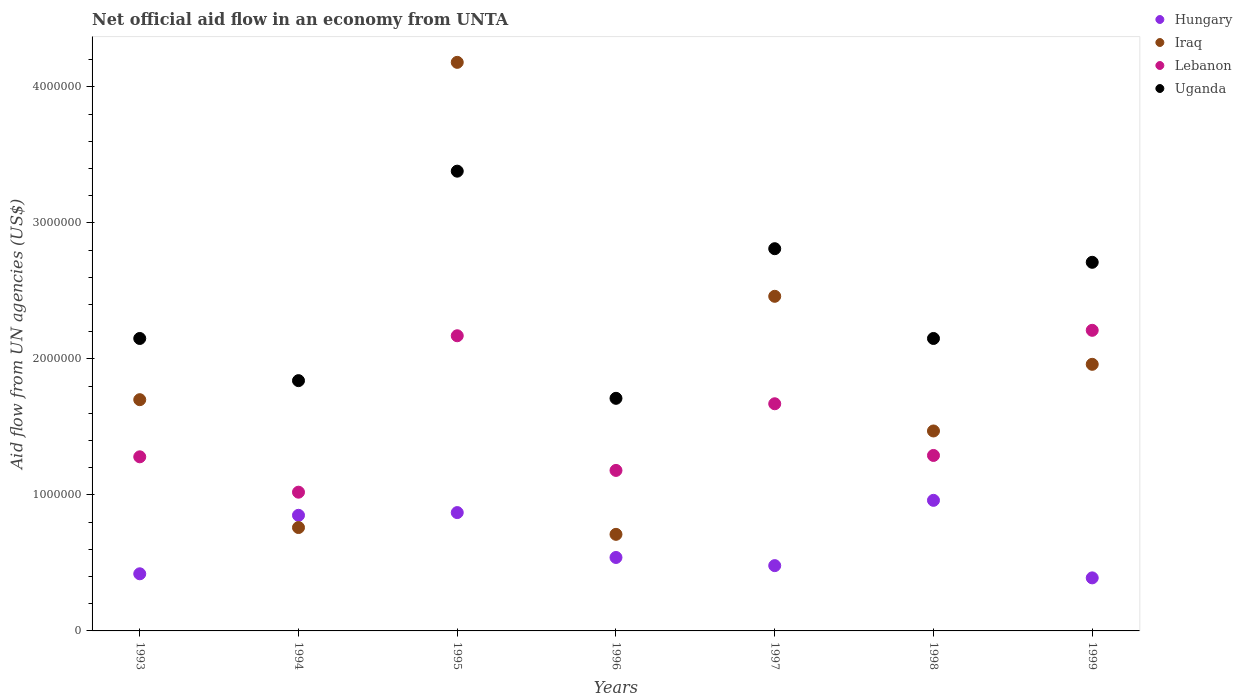Is the number of dotlines equal to the number of legend labels?
Offer a terse response. Yes. What is the net official aid flow in Lebanon in 1996?
Provide a succinct answer. 1.18e+06. Across all years, what is the maximum net official aid flow in Lebanon?
Make the answer very short. 2.21e+06. Across all years, what is the minimum net official aid flow in Iraq?
Make the answer very short. 7.10e+05. What is the total net official aid flow in Hungary in the graph?
Give a very brief answer. 4.51e+06. What is the difference between the net official aid flow in Hungary in 1994 and that in 1996?
Ensure brevity in your answer.  3.10e+05. What is the difference between the net official aid flow in Uganda in 1993 and the net official aid flow in Hungary in 1999?
Ensure brevity in your answer.  1.76e+06. What is the average net official aid flow in Iraq per year?
Keep it short and to the point. 1.89e+06. In the year 1996, what is the difference between the net official aid flow in Hungary and net official aid flow in Uganda?
Offer a very short reply. -1.17e+06. What is the ratio of the net official aid flow in Iraq in 1996 to that in 1997?
Provide a succinct answer. 0.29. Is the net official aid flow in Uganda in 1996 less than that in 1997?
Keep it short and to the point. Yes. Is the difference between the net official aid flow in Hungary in 1995 and 1998 greater than the difference between the net official aid flow in Uganda in 1995 and 1998?
Give a very brief answer. No. What is the difference between the highest and the second highest net official aid flow in Uganda?
Provide a succinct answer. 5.70e+05. What is the difference between the highest and the lowest net official aid flow in Lebanon?
Your answer should be compact. 1.19e+06. In how many years, is the net official aid flow in Iraq greater than the average net official aid flow in Iraq taken over all years?
Offer a very short reply. 3. Is it the case that in every year, the sum of the net official aid flow in Lebanon and net official aid flow in Iraq  is greater than the sum of net official aid flow in Hungary and net official aid flow in Uganda?
Provide a succinct answer. No. Is the net official aid flow in Iraq strictly less than the net official aid flow in Hungary over the years?
Offer a terse response. No. What is the difference between two consecutive major ticks on the Y-axis?
Offer a terse response. 1.00e+06. Does the graph contain grids?
Keep it short and to the point. No. How are the legend labels stacked?
Ensure brevity in your answer.  Vertical. What is the title of the graph?
Offer a very short reply. Net official aid flow in an economy from UNTA. Does "United States" appear as one of the legend labels in the graph?
Make the answer very short. No. What is the label or title of the X-axis?
Make the answer very short. Years. What is the label or title of the Y-axis?
Your answer should be compact. Aid flow from UN agencies (US$). What is the Aid flow from UN agencies (US$) of Iraq in 1993?
Offer a terse response. 1.70e+06. What is the Aid flow from UN agencies (US$) in Lebanon in 1993?
Offer a terse response. 1.28e+06. What is the Aid flow from UN agencies (US$) in Uganda in 1993?
Offer a very short reply. 2.15e+06. What is the Aid flow from UN agencies (US$) in Hungary in 1994?
Offer a terse response. 8.50e+05. What is the Aid flow from UN agencies (US$) in Iraq in 1994?
Provide a short and direct response. 7.60e+05. What is the Aid flow from UN agencies (US$) of Lebanon in 1994?
Offer a terse response. 1.02e+06. What is the Aid flow from UN agencies (US$) of Uganda in 1994?
Ensure brevity in your answer.  1.84e+06. What is the Aid flow from UN agencies (US$) in Hungary in 1995?
Provide a succinct answer. 8.70e+05. What is the Aid flow from UN agencies (US$) of Iraq in 1995?
Your response must be concise. 4.18e+06. What is the Aid flow from UN agencies (US$) in Lebanon in 1995?
Your response must be concise. 2.17e+06. What is the Aid flow from UN agencies (US$) in Uganda in 1995?
Your answer should be very brief. 3.38e+06. What is the Aid flow from UN agencies (US$) in Hungary in 1996?
Your answer should be compact. 5.40e+05. What is the Aid flow from UN agencies (US$) in Iraq in 1996?
Your response must be concise. 7.10e+05. What is the Aid flow from UN agencies (US$) in Lebanon in 1996?
Offer a terse response. 1.18e+06. What is the Aid flow from UN agencies (US$) in Uganda in 1996?
Offer a very short reply. 1.71e+06. What is the Aid flow from UN agencies (US$) of Hungary in 1997?
Your answer should be very brief. 4.80e+05. What is the Aid flow from UN agencies (US$) of Iraq in 1997?
Your response must be concise. 2.46e+06. What is the Aid flow from UN agencies (US$) in Lebanon in 1997?
Keep it short and to the point. 1.67e+06. What is the Aid flow from UN agencies (US$) of Uganda in 1997?
Provide a succinct answer. 2.81e+06. What is the Aid flow from UN agencies (US$) of Hungary in 1998?
Ensure brevity in your answer.  9.60e+05. What is the Aid flow from UN agencies (US$) of Iraq in 1998?
Your response must be concise. 1.47e+06. What is the Aid flow from UN agencies (US$) in Lebanon in 1998?
Provide a succinct answer. 1.29e+06. What is the Aid flow from UN agencies (US$) in Uganda in 1998?
Your answer should be compact. 2.15e+06. What is the Aid flow from UN agencies (US$) in Hungary in 1999?
Give a very brief answer. 3.90e+05. What is the Aid flow from UN agencies (US$) in Iraq in 1999?
Keep it short and to the point. 1.96e+06. What is the Aid flow from UN agencies (US$) of Lebanon in 1999?
Give a very brief answer. 2.21e+06. What is the Aid flow from UN agencies (US$) in Uganda in 1999?
Your answer should be compact. 2.71e+06. Across all years, what is the maximum Aid flow from UN agencies (US$) of Hungary?
Provide a short and direct response. 9.60e+05. Across all years, what is the maximum Aid flow from UN agencies (US$) of Iraq?
Give a very brief answer. 4.18e+06. Across all years, what is the maximum Aid flow from UN agencies (US$) in Lebanon?
Ensure brevity in your answer.  2.21e+06. Across all years, what is the maximum Aid flow from UN agencies (US$) of Uganda?
Your answer should be compact. 3.38e+06. Across all years, what is the minimum Aid flow from UN agencies (US$) in Iraq?
Give a very brief answer. 7.10e+05. Across all years, what is the minimum Aid flow from UN agencies (US$) in Lebanon?
Give a very brief answer. 1.02e+06. Across all years, what is the minimum Aid flow from UN agencies (US$) of Uganda?
Offer a terse response. 1.71e+06. What is the total Aid flow from UN agencies (US$) of Hungary in the graph?
Your response must be concise. 4.51e+06. What is the total Aid flow from UN agencies (US$) of Iraq in the graph?
Your answer should be very brief. 1.32e+07. What is the total Aid flow from UN agencies (US$) in Lebanon in the graph?
Your answer should be compact. 1.08e+07. What is the total Aid flow from UN agencies (US$) of Uganda in the graph?
Offer a terse response. 1.68e+07. What is the difference between the Aid flow from UN agencies (US$) in Hungary in 1993 and that in 1994?
Provide a succinct answer. -4.30e+05. What is the difference between the Aid flow from UN agencies (US$) of Iraq in 1993 and that in 1994?
Provide a short and direct response. 9.40e+05. What is the difference between the Aid flow from UN agencies (US$) of Lebanon in 1993 and that in 1994?
Make the answer very short. 2.60e+05. What is the difference between the Aid flow from UN agencies (US$) in Hungary in 1993 and that in 1995?
Give a very brief answer. -4.50e+05. What is the difference between the Aid flow from UN agencies (US$) in Iraq in 1993 and that in 1995?
Provide a short and direct response. -2.48e+06. What is the difference between the Aid flow from UN agencies (US$) of Lebanon in 1993 and that in 1995?
Your answer should be very brief. -8.90e+05. What is the difference between the Aid flow from UN agencies (US$) of Uganda in 1993 and that in 1995?
Offer a very short reply. -1.23e+06. What is the difference between the Aid flow from UN agencies (US$) in Hungary in 1993 and that in 1996?
Your answer should be very brief. -1.20e+05. What is the difference between the Aid flow from UN agencies (US$) of Iraq in 1993 and that in 1996?
Give a very brief answer. 9.90e+05. What is the difference between the Aid flow from UN agencies (US$) of Uganda in 1993 and that in 1996?
Provide a succinct answer. 4.40e+05. What is the difference between the Aid flow from UN agencies (US$) of Iraq in 1993 and that in 1997?
Your answer should be compact. -7.60e+05. What is the difference between the Aid flow from UN agencies (US$) of Lebanon in 1993 and that in 1997?
Your answer should be very brief. -3.90e+05. What is the difference between the Aid flow from UN agencies (US$) of Uganda in 1993 and that in 1997?
Provide a succinct answer. -6.60e+05. What is the difference between the Aid flow from UN agencies (US$) in Hungary in 1993 and that in 1998?
Your response must be concise. -5.40e+05. What is the difference between the Aid flow from UN agencies (US$) in Iraq in 1993 and that in 1999?
Ensure brevity in your answer.  -2.60e+05. What is the difference between the Aid flow from UN agencies (US$) in Lebanon in 1993 and that in 1999?
Your answer should be very brief. -9.30e+05. What is the difference between the Aid flow from UN agencies (US$) in Uganda in 1993 and that in 1999?
Make the answer very short. -5.60e+05. What is the difference between the Aid flow from UN agencies (US$) of Iraq in 1994 and that in 1995?
Offer a terse response. -3.42e+06. What is the difference between the Aid flow from UN agencies (US$) of Lebanon in 1994 and that in 1995?
Offer a terse response. -1.15e+06. What is the difference between the Aid flow from UN agencies (US$) in Uganda in 1994 and that in 1995?
Your answer should be compact. -1.54e+06. What is the difference between the Aid flow from UN agencies (US$) of Hungary in 1994 and that in 1996?
Your answer should be very brief. 3.10e+05. What is the difference between the Aid flow from UN agencies (US$) of Iraq in 1994 and that in 1996?
Your answer should be compact. 5.00e+04. What is the difference between the Aid flow from UN agencies (US$) in Iraq in 1994 and that in 1997?
Offer a terse response. -1.70e+06. What is the difference between the Aid flow from UN agencies (US$) of Lebanon in 1994 and that in 1997?
Offer a very short reply. -6.50e+05. What is the difference between the Aid flow from UN agencies (US$) in Uganda in 1994 and that in 1997?
Your response must be concise. -9.70e+05. What is the difference between the Aid flow from UN agencies (US$) of Iraq in 1994 and that in 1998?
Your answer should be compact. -7.10e+05. What is the difference between the Aid flow from UN agencies (US$) of Lebanon in 1994 and that in 1998?
Offer a terse response. -2.70e+05. What is the difference between the Aid flow from UN agencies (US$) of Uganda in 1994 and that in 1998?
Your answer should be compact. -3.10e+05. What is the difference between the Aid flow from UN agencies (US$) in Iraq in 1994 and that in 1999?
Give a very brief answer. -1.20e+06. What is the difference between the Aid flow from UN agencies (US$) of Lebanon in 1994 and that in 1999?
Your answer should be very brief. -1.19e+06. What is the difference between the Aid flow from UN agencies (US$) of Uganda in 1994 and that in 1999?
Your response must be concise. -8.70e+05. What is the difference between the Aid flow from UN agencies (US$) in Iraq in 1995 and that in 1996?
Keep it short and to the point. 3.47e+06. What is the difference between the Aid flow from UN agencies (US$) of Lebanon in 1995 and that in 1996?
Your response must be concise. 9.90e+05. What is the difference between the Aid flow from UN agencies (US$) in Uganda in 1995 and that in 1996?
Keep it short and to the point. 1.67e+06. What is the difference between the Aid flow from UN agencies (US$) of Hungary in 1995 and that in 1997?
Keep it short and to the point. 3.90e+05. What is the difference between the Aid flow from UN agencies (US$) in Iraq in 1995 and that in 1997?
Provide a short and direct response. 1.72e+06. What is the difference between the Aid flow from UN agencies (US$) in Uganda in 1995 and that in 1997?
Keep it short and to the point. 5.70e+05. What is the difference between the Aid flow from UN agencies (US$) of Iraq in 1995 and that in 1998?
Provide a succinct answer. 2.71e+06. What is the difference between the Aid flow from UN agencies (US$) of Lebanon in 1995 and that in 1998?
Ensure brevity in your answer.  8.80e+05. What is the difference between the Aid flow from UN agencies (US$) of Uganda in 1995 and that in 1998?
Your answer should be compact. 1.23e+06. What is the difference between the Aid flow from UN agencies (US$) of Iraq in 1995 and that in 1999?
Offer a very short reply. 2.22e+06. What is the difference between the Aid flow from UN agencies (US$) of Lebanon in 1995 and that in 1999?
Offer a very short reply. -4.00e+04. What is the difference between the Aid flow from UN agencies (US$) in Uganda in 1995 and that in 1999?
Your response must be concise. 6.70e+05. What is the difference between the Aid flow from UN agencies (US$) of Hungary in 1996 and that in 1997?
Ensure brevity in your answer.  6.00e+04. What is the difference between the Aid flow from UN agencies (US$) in Iraq in 1996 and that in 1997?
Make the answer very short. -1.75e+06. What is the difference between the Aid flow from UN agencies (US$) of Lebanon in 1996 and that in 1997?
Offer a terse response. -4.90e+05. What is the difference between the Aid flow from UN agencies (US$) of Uganda in 1996 and that in 1997?
Your answer should be compact. -1.10e+06. What is the difference between the Aid flow from UN agencies (US$) of Hungary in 1996 and that in 1998?
Offer a very short reply. -4.20e+05. What is the difference between the Aid flow from UN agencies (US$) of Iraq in 1996 and that in 1998?
Your answer should be very brief. -7.60e+05. What is the difference between the Aid flow from UN agencies (US$) of Lebanon in 1996 and that in 1998?
Offer a terse response. -1.10e+05. What is the difference between the Aid flow from UN agencies (US$) of Uganda in 1996 and that in 1998?
Your answer should be very brief. -4.40e+05. What is the difference between the Aid flow from UN agencies (US$) of Hungary in 1996 and that in 1999?
Give a very brief answer. 1.50e+05. What is the difference between the Aid flow from UN agencies (US$) in Iraq in 1996 and that in 1999?
Your answer should be compact. -1.25e+06. What is the difference between the Aid flow from UN agencies (US$) of Lebanon in 1996 and that in 1999?
Offer a very short reply. -1.03e+06. What is the difference between the Aid flow from UN agencies (US$) in Hungary in 1997 and that in 1998?
Make the answer very short. -4.80e+05. What is the difference between the Aid flow from UN agencies (US$) of Iraq in 1997 and that in 1998?
Your answer should be very brief. 9.90e+05. What is the difference between the Aid flow from UN agencies (US$) of Uganda in 1997 and that in 1998?
Offer a terse response. 6.60e+05. What is the difference between the Aid flow from UN agencies (US$) of Iraq in 1997 and that in 1999?
Provide a short and direct response. 5.00e+05. What is the difference between the Aid flow from UN agencies (US$) of Lebanon in 1997 and that in 1999?
Give a very brief answer. -5.40e+05. What is the difference between the Aid flow from UN agencies (US$) in Hungary in 1998 and that in 1999?
Give a very brief answer. 5.70e+05. What is the difference between the Aid flow from UN agencies (US$) of Iraq in 1998 and that in 1999?
Your answer should be very brief. -4.90e+05. What is the difference between the Aid flow from UN agencies (US$) of Lebanon in 1998 and that in 1999?
Provide a succinct answer. -9.20e+05. What is the difference between the Aid flow from UN agencies (US$) in Uganda in 1998 and that in 1999?
Keep it short and to the point. -5.60e+05. What is the difference between the Aid flow from UN agencies (US$) in Hungary in 1993 and the Aid flow from UN agencies (US$) in Iraq in 1994?
Offer a very short reply. -3.40e+05. What is the difference between the Aid flow from UN agencies (US$) in Hungary in 1993 and the Aid flow from UN agencies (US$) in Lebanon in 1994?
Keep it short and to the point. -6.00e+05. What is the difference between the Aid flow from UN agencies (US$) in Hungary in 1993 and the Aid flow from UN agencies (US$) in Uganda in 1994?
Provide a succinct answer. -1.42e+06. What is the difference between the Aid flow from UN agencies (US$) of Iraq in 1993 and the Aid flow from UN agencies (US$) of Lebanon in 1994?
Ensure brevity in your answer.  6.80e+05. What is the difference between the Aid flow from UN agencies (US$) in Lebanon in 1993 and the Aid flow from UN agencies (US$) in Uganda in 1994?
Ensure brevity in your answer.  -5.60e+05. What is the difference between the Aid flow from UN agencies (US$) of Hungary in 1993 and the Aid flow from UN agencies (US$) of Iraq in 1995?
Make the answer very short. -3.76e+06. What is the difference between the Aid flow from UN agencies (US$) of Hungary in 1993 and the Aid flow from UN agencies (US$) of Lebanon in 1995?
Offer a very short reply. -1.75e+06. What is the difference between the Aid flow from UN agencies (US$) of Hungary in 1993 and the Aid flow from UN agencies (US$) of Uganda in 1995?
Offer a very short reply. -2.96e+06. What is the difference between the Aid flow from UN agencies (US$) in Iraq in 1993 and the Aid flow from UN agencies (US$) in Lebanon in 1995?
Ensure brevity in your answer.  -4.70e+05. What is the difference between the Aid flow from UN agencies (US$) in Iraq in 1993 and the Aid flow from UN agencies (US$) in Uganda in 1995?
Your response must be concise. -1.68e+06. What is the difference between the Aid flow from UN agencies (US$) in Lebanon in 1993 and the Aid flow from UN agencies (US$) in Uganda in 1995?
Give a very brief answer. -2.10e+06. What is the difference between the Aid flow from UN agencies (US$) of Hungary in 1993 and the Aid flow from UN agencies (US$) of Iraq in 1996?
Make the answer very short. -2.90e+05. What is the difference between the Aid flow from UN agencies (US$) of Hungary in 1993 and the Aid flow from UN agencies (US$) of Lebanon in 1996?
Make the answer very short. -7.60e+05. What is the difference between the Aid flow from UN agencies (US$) of Hungary in 1993 and the Aid flow from UN agencies (US$) of Uganda in 1996?
Your response must be concise. -1.29e+06. What is the difference between the Aid flow from UN agencies (US$) in Iraq in 1993 and the Aid flow from UN agencies (US$) in Lebanon in 1996?
Your response must be concise. 5.20e+05. What is the difference between the Aid flow from UN agencies (US$) of Lebanon in 1993 and the Aid flow from UN agencies (US$) of Uganda in 1996?
Provide a short and direct response. -4.30e+05. What is the difference between the Aid flow from UN agencies (US$) of Hungary in 1993 and the Aid flow from UN agencies (US$) of Iraq in 1997?
Offer a very short reply. -2.04e+06. What is the difference between the Aid flow from UN agencies (US$) of Hungary in 1993 and the Aid flow from UN agencies (US$) of Lebanon in 1997?
Make the answer very short. -1.25e+06. What is the difference between the Aid flow from UN agencies (US$) of Hungary in 1993 and the Aid flow from UN agencies (US$) of Uganda in 1997?
Offer a very short reply. -2.39e+06. What is the difference between the Aid flow from UN agencies (US$) of Iraq in 1993 and the Aid flow from UN agencies (US$) of Uganda in 1997?
Your answer should be compact. -1.11e+06. What is the difference between the Aid flow from UN agencies (US$) in Lebanon in 1993 and the Aid flow from UN agencies (US$) in Uganda in 1997?
Provide a short and direct response. -1.53e+06. What is the difference between the Aid flow from UN agencies (US$) of Hungary in 1993 and the Aid flow from UN agencies (US$) of Iraq in 1998?
Your response must be concise. -1.05e+06. What is the difference between the Aid flow from UN agencies (US$) of Hungary in 1993 and the Aid flow from UN agencies (US$) of Lebanon in 1998?
Your answer should be very brief. -8.70e+05. What is the difference between the Aid flow from UN agencies (US$) of Hungary in 1993 and the Aid flow from UN agencies (US$) of Uganda in 1998?
Give a very brief answer. -1.73e+06. What is the difference between the Aid flow from UN agencies (US$) in Iraq in 1993 and the Aid flow from UN agencies (US$) in Uganda in 1998?
Keep it short and to the point. -4.50e+05. What is the difference between the Aid flow from UN agencies (US$) of Lebanon in 1993 and the Aid flow from UN agencies (US$) of Uganda in 1998?
Your answer should be compact. -8.70e+05. What is the difference between the Aid flow from UN agencies (US$) of Hungary in 1993 and the Aid flow from UN agencies (US$) of Iraq in 1999?
Your answer should be very brief. -1.54e+06. What is the difference between the Aid flow from UN agencies (US$) of Hungary in 1993 and the Aid flow from UN agencies (US$) of Lebanon in 1999?
Provide a short and direct response. -1.79e+06. What is the difference between the Aid flow from UN agencies (US$) in Hungary in 1993 and the Aid flow from UN agencies (US$) in Uganda in 1999?
Ensure brevity in your answer.  -2.29e+06. What is the difference between the Aid flow from UN agencies (US$) of Iraq in 1993 and the Aid flow from UN agencies (US$) of Lebanon in 1999?
Make the answer very short. -5.10e+05. What is the difference between the Aid flow from UN agencies (US$) in Iraq in 1993 and the Aid flow from UN agencies (US$) in Uganda in 1999?
Ensure brevity in your answer.  -1.01e+06. What is the difference between the Aid flow from UN agencies (US$) in Lebanon in 1993 and the Aid flow from UN agencies (US$) in Uganda in 1999?
Provide a short and direct response. -1.43e+06. What is the difference between the Aid flow from UN agencies (US$) of Hungary in 1994 and the Aid flow from UN agencies (US$) of Iraq in 1995?
Your response must be concise. -3.33e+06. What is the difference between the Aid flow from UN agencies (US$) in Hungary in 1994 and the Aid flow from UN agencies (US$) in Lebanon in 1995?
Your response must be concise. -1.32e+06. What is the difference between the Aid flow from UN agencies (US$) in Hungary in 1994 and the Aid flow from UN agencies (US$) in Uganda in 1995?
Your response must be concise. -2.53e+06. What is the difference between the Aid flow from UN agencies (US$) of Iraq in 1994 and the Aid flow from UN agencies (US$) of Lebanon in 1995?
Your answer should be very brief. -1.41e+06. What is the difference between the Aid flow from UN agencies (US$) in Iraq in 1994 and the Aid flow from UN agencies (US$) in Uganda in 1995?
Provide a succinct answer. -2.62e+06. What is the difference between the Aid flow from UN agencies (US$) of Lebanon in 1994 and the Aid flow from UN agencies (US$) of Uganda in 1995?
Ensure brevity in your answer.  -2.36e+06. What is the difference between the Aid flow from UN agencies (US$) in Hungary in 1994 and the Aid flow from UN agencies (US$) in Iraq in 1996?
Ensure brevity in your answer.  1.40e+05. What is the difference between the Aid flow from UN agencies (US$) of Hungary in 1994 and the Aid flow from UN agencies (US$) of Lebanon in 1996?
Your response must be concise. -3.30e+05. What is the difference between the Aid flow from UN agencies (US$) of Hungary in 1994 and the Aid flow from UN agencies (US$) of Uganda in 1996?
Offer a terse response. -8.60e+05. What is the difference between the Aid flow from UN agencies (US$) of Iraq in 1994 and the Aid flow from UN agencies (US$) of Lebanon in 1996?
Keep it short and to the point. -4.20e+05. What is the difference between the Aid flow from UN agencies (US$) of Iraq in 1994 and the Aid flow from UN agencies (US$) of Uganda in 1996?
Your response must be concise. -9.50e+05. What is the difference between the Aid flow from UN agencies (US$) in Lebanon in 1994 and the Aid flow from UN agencies (US$) in Uganda in 1996?
Your answer should be compact. -6.90e+05. What is the difference between the Aid flow from UN agencies (US$) in Hungary in 1994 and the Aid flow from UN agencies (US$) in Iraq in 1997?
Ensure brevity in your answer.  -1.61e+06. What is the difference between the Aid flow from UN agencies (US$) in Hungary in 1994 and the Aid flow from UN agencies (US$) in Lebanon in 1997?
Your answer should be compact. -8.20e+05. What is the difference between the Aid flow from UN agencies (US$) in Hungary in 1994 and the Aid flow from UN agencies (US$) in Uganda in 1997?
Offer a very short reply. -1.96e+06. What is the difference between the Aid flow from UN agencies (US$) of Iraq in 1994 and the Aid flow from UN agencies (US$) of Lebanon in 1997?
Offer a terse response. -9.10e+05. What is the difference between the Aid flow from UN agencies (US$) in Iraq in 1994 and the Aid flow from UN agencies (US$) in Uganda in 1997?
Keep it short and to the point. -2.05e+06. What is the difference between the Aid flow from UN agencies (US$) of Lebanon in 1994 and the Aid flow from UN agencies (US$) of Uganda in 1997?
Provide a short and direct response. -1.79e+06. What is the difference between the Aid flow from UN agencies (US$) in Hungary in 1994 and the Aid flow from UN agencies (US$) in Iraq in 1998?
Offer a very short reply. -6.20e+05. What is the difference between the Aid flow from UN agencies (US$) in Hungary in 1994 and the Aid flow from UN agencies (US$) in Lebanon in 1998?
Provide a short and direct response. -4.40e+05. What is the difference between the Aid flow from UN agencies (US$) in Hungary in 1994 and the Aid flow from UN agencies (US$) in Uganda in 1998?
Your answer should be compact. -1.30e+06. What is the difference between the Aid flow from UN agencies (US$) in Iraq in 1994 and the Aid flow from UN agencies (US$) in Lebanon in 1998?
Keep it short and to the point. -5.30e+05. What is the difference between the Aid flow from UN agencies (US$) in Iraq in 1994 and the Aid flow from UN agencies (US$) in Uganda in 1998?
Keep it short and to the point. -1.39e+06. What is the difference between the Aid flow from UN agencies (US$) of Lebanon in 1994 and the Aid flow from UN agencies (US$) of Uganda in 1998?
Ensure brevity in your answer.  -1.13e+06. What is the difference between the Aid flow from UN agencies (US$) in Hungary in 1994 and the Aid flow from UN agencies (US$) in Iraq in 1999?
Your answer should be very brief. -1.11e+06. What is the difference between the Aid flow from UN agencies (US$) of Hungary in 1994 and the Aid flow from UN agencies (US$) of Lebanon in 1999?
Your response must be concise. -1.36e+06. What is the difference between the Aid flow from UN agencies (US$) of Hungary in 1994 and the Aid flow from UN agencies (US$) of Uganda in 1999?
Keep it short and to the point. -1.86e+06. What is the difference between the Aid flow from UN agencies (US$) of Iraq in 1994 and the Aid flow from UN agencies (US$) of Lebanon in 1999?
Ensure brevity in your answer.  -1.45e+06. What is the difference between the Aid flow from UN agencies (US$) in Iraq in 1994 and the Aid flow from UN agencies (US$) in Uganda in 1999?
Provide a succinct answer. -1.95e+06. What is the difference between the Aid flow from UN agencies (US$) in Lebanon in 1994 and the Aid flow from UN agencies (US$) in Uganda in 1999?
Give a very brief answer. -1.69e+06. What is the difference between the Aid flow from UN agencies (US$) in Hungary in 1995 and the Aid flow from UN agencies (US$) in Iraq in 1996?
Provide a succinct answer. 1.60e+05. What is the difference between the Aid flow from UN agencies (US$) in Hungary in 1995 and the Aid flow from UN agencies (US$) in Lebanon in 1996?
Offer a terse response. -3.10e+05. What is the difference between the Aid flow from UN agencies (US$) of Hungary in 1995 and the Aid flow from UN agencies (US$) of Uganda in 1996?
Provide a succinct answer. -8.40e+05. What is the difference between the Aid flow from UN agencies (US$) in Iraq in 1995 and the Aid flow from UN agencies (US$) in Uganda in 1996?
Keep it short and to the point. 2.47e+06. What is the difference between the Aid flow from UN agencies (US$) in Lebanon in 1995 and the Aid flow from UN agencies (US$) in Uganda in 1996?
Ensure brevity in your answer.  4.60e+05. What is the difference between the Aid flow from UN agencies (US$) in Hungary in 1995 and the Aid flow from UN agencies (US$) in Iraq in 1997?
Ensure brevity in your answer.  -1.59e+06. What is the difference between the Aid flow from UN agencies (US$) of Hungary in 1995 and the Aid flow from UN agencies (US$) of Lebanon in 1997?
Make the answer very short. -8.00e+05. What is the difference between the Aid flow from UN agencies (US$) in Hungary in 1995 and the Aid flow from UN agencies (US$) in Uganda in 1997?
Offer a terse response. -1.94e+06. What is the difference between the Aid flow from UN agencies (US$) of Iraq in 1995 and the Aid flow from UN agencies (US$) of Lebanon in 1997?
Offer a terse response. 2.51e+06. What is the difference between the Aid flow from UN agencies (US$) of Iraq in 1995 and the Aid flow from UN agencies (US$) of Uganda in 1997?
Offer a very short reply. 1.37e+06. What is the difference between the Aid flow from UN agencies (US$) of Lebanon in 1995 and the Aid flow from UN agencies (US$) of Uganda in 1997?
Make the answer very short. -6.40e+05. What is the difference between the Aid flow from UN agencies (US$) of Hungary in 1995 and the Aid flow from UN agencies (US$) of Iraq in 1998?
Offer a terse response. -6.00e+05. What is the difference between the Aid flow from UN agencies (US$) in Hungary in 1995 and the Aid flow from UN agencies (US$) in Lebanon in 1998?
Provide a succinct answer. -4.20e+05. What is the difference between the Aid flow from UN agencies (US$) of Hungary in 1995 and the Aid flow from UN agencies (US$) of Uganda in 1998?
Keep it short and to the point. -1.28e+06. What is the difference between the Aid flow from UN agencies (US$) in Iraq in 1995 and the Aid flow from UN agencies (US$) in Lebanon in 1998?
Offer a terse response. 2.89e+06. What is the difference between the Aid flow from UN agencies (US$) in Iraq in 1995 and the Aid flow from UN agencies (US$) in Uganda in 1998?
Your answer should be very brief. 2.03e+06. What is the difference between the Aid flow from UN agencies (US$) of Hungary in 1995 and the Aid flow from UN agencies (US$) of Iraq in 1999?
Your answer should be compact. -1.09e+06. What is the difference between the Aid flow from UN agencies (US$) in Hungary in 1995 and the Aid flow from UN agencies (US$) in Lebanon in 1999?
Your response must be concise. -1.34e+06. What is the difference between the Aid flow from UN agencies (US$) in Hungary in 1995 and the Aid flow from UN agencies (US$) in Uganda in 1999?
Your answer should be very brief. -1.84e+06. What is the difference between the Aid flow from UN agencies (US$) in Iraq in 1995 and the Aid flow from UN agencies (US$) in Lebanon in 1999?
Your answer should be compact. 1.97e+06. What is the difference between the Aid flow from UN agencies (US$) in Iraq in 1995 and the Aid flow from UN agencies (US$) in Uganda in 1999?
Offer a terse response. 1.47e+06. What is the difference between the Aid flow from UN agencies (US$) in Lebanon in 1995 and the Aid flow from UN agencies (US$) in Uganda in 1999?
Offer a terse response. -5.40e+05. What is the difference between the Aid flow from UN agencies (US$) in Hungary in 1996 and the Aid flow from UN agencies (US$) in Iraq in 1997?
Ensure brevity in your answer.  -1.92e+06. What is the difference between the Aid flow from UN agencies (US$) in Hungary in 1996 and the Aid flow from UN agencies (US$) in Lebanon in 1997?
Your response must be concise. -1.13e+06. What is the difference between the Aid flow from UN agencies (US$) of Hungary in 1996 and the Aid flow from UN agencies (US$) of Uganda in 1997?
Your answer should be very brief. -2.27e+06. What is the difference between the Aid flow from UN agencies (US$) in Iraq in 1996 and the Aid flow from UN agencies (US$) in Lebanon in 1997?
Ensure brevity in your answer.  -9.60e+05. What is the difference between the Aid flow from UN agencies (US$) of Iraq in 1996 and the Aid flow from UN agencies (US$) of Uganda in 1997?
Provide a short and direct response. -2.10e+06. What is the difference between the Aid flow from UN agencies (US$) in Lebanon in 1996 and the Aid flow from UN agencies (US$) in Uganda in 1997?
Make the answer very short. -1.63e+06. What is the difference between the Aid flow from UN agencies (US$) in Hungary in 1996 and the Aid flow from UN agencies (US$) in Iraq in 1998?
Make the answer very short. -9.30e+05. What is the difference between the Aid flow from UN agencies (US$) of Hungary in 1996 and the Aid flow from UN agencies (US$) of Lebanon in 1998?
Your answer should be compact. -7.50e+05. What is the difference between the Aid flow from UN agencies (US$) in Hungary in 1996 and the Aid flow from UN agencies (US$) in Uganda in 1998?
Ensure brevity in your answer.  -1.61e+06. What is the difference between the Aid flow from UN agencies (US$) in Iraq in 1996 and the Aid flow from UN agencies (US$) in Lebanon in 1998?
Your answer should be very brief. -5.80e+05. What is the difference between the Aid flow from UN agencies (US$) in Iraq in 1996 and the Aid flow from UN agencies (US$) in Uganda in 1998?
Make the answer very short. -1.44e+06. What is the difference between the Aid flow from UN agencies (US$) of Lebanon in 1996 and the Aid flow from UN agencies (US$) of Uganda in 1998?
Offer a very short reply. -9.70e+05. What is the difference between the Aid flow from UN agencies (US$) in Hungary in 1996 and the Aid flow from UN agencies (US$) in Iraq in 1999?
Ensure brevity in your answer.  -1.42e+06. What is the difference between the Aid flow from UN agencies (US$) in Hungary in 1996 and the Aid flow from UN agencies (US$) in Lebanon in 1999?
Provide a succinct answer. -1.67e+06. What is the difference between the Aid flow from UN agencies (US$) of Hungary in 1996 and the Aid flow from UN agencies (US$) of Uganda in 1999?
Provide a short and direct response. -2.17e+06. What is the difference between the Aid flow from UN agencies (US$) in Iraq in 1996 and the Aid flow from UN agencies (US$) in Lebanon in 1999?
Provide a short and direct response. -1.50e+06. What is the difference between the Aid flow from UN agencies (US$) of Iraq in 1996 and the Aid flow from UN agencies (US$) of Uganda in 1999?
Offer a terse response. -2.00e+06. What is the difference between the Aid flow from UN agencies (US$) of Lebanon in 1996 and the Aid flow from UN agencies (US$) of Uganda in 1999?
Offer a terse response. -1.53e+06. What is the difference between the Aid flow from UN agencies (US$) of Hungary in 1997 and the Aid flow from UN agencies (US$) of Iraq in 1998?
Your answer should be compact. -9.90e+05. What is the difference between the Aid flow from UN agencies (US$) in Hungary in 1997 and the Aid flow from UN agencies (US$) in Lebanon in 1998?
Keep it short and to the point. -8.10e+05. What is the difference between the Aid flow from UN agencies (US$) of Hungary in 1997 and the Aid flow from UN agencies (US$) of Uganda in 1998?
Your response must be concise. -1.67e+06. What is the difference between the Aid flow from UN agencies (US$) of Iraq in 1997 and the Aid flow from UN agencies (US$) of Lebanon in 1998?
Make the answer very short. 1.17e+06. What is the difference between the Aid flow from UN agencies (US$) in Iraq in 1997 and the Aid flow from UN agencies (US$) in Uganda in 1998?
Offer a terse response. 3.10e+05. What is the difference between the Aid flow from UN agencies (US$) of Lebanon in 1997 and the Aid flow from UN agencies (US$) of Uganda in 1998?
Provide a succinct answer. -4.80e+05. What is the difference between the Aid flow from UN agencies (US$) in Hungary in 1997 and the Aid flow from UN agencies (US$) in Iraq in 1999?
Keep it short and to the point. -1.48e+06. What is the difference between the Aid flow from UN agencies (US$) of Hungary in 1997 and the Aid flow from UN agencies (US$) of Lebanon in 1999?
Give a very brief answer. -1.73e+06. What is the difference between the Aid flow from UN agencies (US$) of Hungary in 1997 and the Aid flow from UN agencies (US$) of Uganda in 1999?
Make the answer very short. -2.23e+06. What is the difference between the Aid flow from UN agencies (US$) in Iraq in 1997 and the Aid flow from UN agencies (US$) in Lebanon in 1999?
Provide a short and direct response. 2.50e+05. What is the difference between the Aid flow from UN agencies (US$) of Lebanon in 1997 and the Aid flow from UN agencies (US$) of Uganda in 1999?
Your answer should be very brief. -1.04e+06. What is the difference between the Aid flow from UN agencies (US$) in Hungary in 1998 and the Aid flow from UN agencies (US$) in Iraq in 1999?
Ensure brevity in your answer.  -1.00e+06. What is the difference between the Aid flow from UN agencies (US$) of Hungary in 1998 and the Aid flow from UN agencies (US$) of Lebanon in 1999?
Give a very brief answer. -1.25e+06. What is the difference between the Aid flow from UN agencies (US$) of Hungary in 1998 and the Aid flow from UN agencies (US$) of Uganda in 1999?
Make the answer very short. -1.75e+06. What is the difference between the Aid flow from UN agencies (US$) of Iraq in 1998 and the Aid flow from UN agencies (US$) of Lebanon in 1999?
Provide a succinct answer. -7.40e+05. What is the difference between the Aid flow from UN agencies (US$) in Iraq in 1998 and the Aid flow from UN agencies (US$) in Uganda in 1999?
Keep it short and to the point. -1.24e+06. What is the difference between the Aid flow from UN agencies (US$) of Lebanon in 1998 and the Aid flow from UN agencies (US$) of Uganda in 1999?
Your response must be concise. -1.42e+06. What is the average Aid flow from UN agencies (US$) in Hungary per year?
Keep it short and to the point. 6.44e+05. What is the average Aid flow from UN agencies (US$) of Iraq per year?
Your answer should be compact. 1.89e+06. What is the average Aid flow from UN agencies (US$) in Lebanon per year?
Offer a terse response. 1.55e+06. What is the average Aid flow from UN agencies (US$) of Uganda per year?
Your response must be concise. 2.39e+06. In the year 1993, what is the difference between the Aid flow from UN agencies (US$) of Hungary and Aid flow from UN agencies (US$) of Iraq?
Your response must be concise. -1.28e+06. In the year 1993, what is the difference between the Aid flow from UN agencies (US$) of Hungary and Aid flow from UN agencies (US$) of Lebanon?
Keep it short and to the point. -8.60e+05. In the year 1993, what is the difference between the Aid flow from UN agencies (US$) of Hungary and Aid flow from UN agencies (US$) of Uganda?
Your response must be concise. -1.73e+06. In the year 1993, what is the difference between the Aid flow from UN agencies (US$) of Iraq and Aid flow from UN agencies (US$) of Uganda?
Your answer should be very brief. -4.50e+05. In the year 1993, what is the difference between the Aid flow from UN agencies (US$) in Lebanon and Aid flow from UN agencies (US$) in Uganda?
Provide a short and direct response. -8.70e+05. In the year 1994, what is the difference between the Aid flow from UN agencies (US$) of Hungary and Aid flow from UN agencies (US$) of Iraq?
Offer a terse response. 9.00e+04. In the year 1994, what is the difference between the Aid flow from UN agencies (US$) in Hungary and Aid flow from UN agencies (US$) in Uganda?
Ensure brevity in your answer.  -9.90e+05. In the year 1994, what is the difference between the Aid flow from UN agencies (US$) in Iraq and Aid flow from UN agencies (US$) in Uganda?
Provide a succinct answer. -1.08e+06. In the year 1994, what is the difference between the Aid flow from UN agencies (US$) in Lebanon and Aid flow from UN agencies (US$) in Uganda?
Your answer should be very brief. -8.20e+05. In the year 1995, what is the difference between the Aid flow from UN agencies (US$) in Hungary and Aid flow from UN agencies (US$) in Iraq?
Your answer should be very brief. -3.31e+06. In the year 1995, what is the difference between the Aid flow from UN agencies (US$) in Hungary and Aid flow from UN agencies (US$) in Lebanon?
Ensure brevity in your answer.  -1.30e+06. In the year 1995, what is the difference between the Aid flow from UN agencies (US$) in Hungary and Aid flow from UN agencies (US$) in Uganda?
Give a very brief answer. -2.51e+06. In the year 1995, what is the difference between the Aid flow from UN agencies (US$) of Iraq and Aid flow from UN agencies (US$) of Lebanon?
Your answer should be compact. 2.01e+06. In the year 1995, what is the difference between the Aid flow from UN agencies (US$) of Iraq and Aid flow from UN agencies (US$) of Uganda?
Your response must be concise. 8.00e+05. In the year 1995, what is the difference between the Aid flow from UN agencies (US$) of Lebanon and Aid flow from UN agencies (US$) of Uganda?
Give a very brief answer. -1.21e+06. In the year 1996, what is the difference between the Aid flow from UN agencies (US$) in Hungary and Aid flow from UN agencies (US$) in Lebanon?
Keep it short and to the point. -6.40e+05. In the year 1996, what is the difference between the Aid flow from UN agencies (US$) of Hungary and Aid flow from UN agencies (US$) of Uganda?
Offer a very short reply. -1.17e+06. In the year 1996, what is the difference between the Aid flow from UN agencies (US$) in Iraq and Aid flow from UN agencies (US$) in Lebanon?
Keep it short and to the point. -4.70e+05. In the year 1996, what is the difference between the Aid flow from UN agencies (US$) in Lebanon and Aid flow from UN agencies (US$) in Uganda?
Give a very brief answer. -5.30e+05. In the year 1997, what is the difference between the Aid flow from UN agencies (US$) in Hungary and Aid flow from UN agencies (US$) in Iraq?
Your answer should be compact. -1.98e+06. In the year 1997, what is the difference between the Aid flow from UN agencies (US$) of Hungary and Aid flow from UN agencies (US$) of Lebanon?
Give a very brief answer. -1.19e+06. In the year 1997, what is the difference between the Aid flow from UN agencies (US$) of Hungary and Aid flow from UN agencies (US$) of Uganda?
Ensure brevity in your answer.  -2.33e+06. In the year 1997, what is the difference between the Aid flow from UN agencies (US$) in Iraq and Aid flow from UN agencies (US$) in Lebanon?
Your answer should be very brief. 7.90e+05. In the year 1997, what is the difference between the Aid flow from UN agencies (US$) of Iraq and Aid flow from UN agencies (US$) of Uganda?
Your response must be concise. -3.50e+05. In the year 1997, what is the difference between the Aid flow from UN agencies (US$) of Lebanon and Aid flow from UN agencies (US$) of Uganda?
Your answer should be compact. -1.14e+06. In the year 1998, what is the difference between the Aid flow from UN agencies (US$) in Hungary and Aid flow from UN agencies (US$) in Iraq?
Offer a very short reply. -5.10e+05. In the year 1998, what is the difference between the Aid flow from UN agencies (US$) of Hungary and Aid flow from UN agencies (US$) of Lebanon?
Provide a succinct answer. -3.30e+05. In the year 1998, what is the difference between the Aid flow from UN agencies (US$) in Hungary and Aid flow from UN agencies (US$) in Uganda?
Keep it short and to the point. -1.19e+06. In the year 1998, what is the difference between the Aid flow from UN agencies (US$) of Iraq and Aid flow from UN agencies (US$) of Lebanon?
Provide a succinct answer. 1.80e+05. In the year 1998, what is the difference between the Aid flow from UN agencies (US$) of Iraq and Aid flow from UN agencies (US$) of Uganda?
Offer a terse response. -6.80e+05. In the year 1998, what is the difference between the Aid flow from UN agencies (US$) in Lebanon and Aid flow from UN agencies (US$) in Uganda?
Give a very brief answer. -8.60e+05. In the year 1999, what is the difference between the Aid flow from UN agencies (US$) in Hungary and Aid flow from UN agencies (US$) in Iraq?
Your answer should be very brief. -1.57e+06. In the year 1999, what is the difference between the Aid flow from UN agencies (US$) in Hungary and Aid flow from UN agencies (US$) in Lebanon?
Keep it short and to the point. -1.82e+06. In the year 1999, what is the difference between the Aid flow from UN agencies (US$) in Hungary and Aid flow from UN agencies (US$) in Uganda?
Your response must be concise. -2.32e+06. In the year 1999, what is the difference between the Aid flow from UN agencies (US$) in Iraq and Aid flow from UN agencies (US$) in Lebanon?
Provide a succinct answer. -2.50e+05. In the year 1999, what is the difference between the Aid flow from UN agencies (US$) of Iraq and Aid flow from UN agencies (US$) of Uganda?
Ensure brevity in your answer.  -7.50e+05. In the year 1999, what is the difference between the Aid flow from UN agencies (US$) in Lebanon and Aid flow from UN agencies (US$) in Uganda?
Your response must be concise. -5.00e+05. What is the ratio of the Aid flow from UN agencies (US$) in Hungary in 1993 to that in 1994?
Offer a very short reply. 0.49. What is the ratio of the Aid flow from UN agencies (US$) of Iraq in 1993 to that in 1994?
Give a very brief answer. 2.24. What is the ratio of the Aid flow from UN agencies (US$) in Lebanon in 1993 to that in 1994?
Your answer should be very brief. 1.25. What is the ratio of the Aid flow from UN agencies (US$) of Uganda in 1993 to that in 1994?
Your answer should be compact. 1.17. What is the ratio of the Aid flow from UN agencies (US$) in Hungary in 1993 to that in 1995?
Give a very brief answer. 0.48. What is the ratio of the Aid flow from UN agencies (US$) of Iraq in 1993 to that in 1995?
Ensure brevity in your answer.  0.41. What is the ratio of the Aid flow from UN agencies (US$) of Lebanon in 1993 to that in 1995?
Keep it short and to the point. 0.59. What is the ratio of the Aid flow from UN agencies (US$) in Uganda in 1993 to that in 1995?
Your answer should be compact. 0.64. What is the ratio of the Aid flow from UN agencies (US$) of Hungary in 1993 to that in 1996?
Give a very brief answer. 0.78. What is the ratio of the Aid flow from UN agencies (US$) of Iraq in 1993 to that in 1996?
Offer a very short reply. 2.39. What is the ratio of the Aid flow from UN agencies (US$) of Lebanon in 1993 to that in 1996?
Offer a very short reply. 1.08. What is the ratio of the Aid flow from UN agencies (US$) in Uganda in 1993 to that in 1996?
Provide a succinct answer. 1.26. What is the ratio of the Aid flow from UN agencies (US$) of Iraq in 1993 to that in 1997?
Give a very brief answer. 0.69. What is the ratio of the Aid flow from UN agencies (US$) in Lebanon in 1993 to that in 1997?
Offer a terse response. 0.77. What is the ratio of the Aid flow from UN agencies (US$) of Uganda in 1993 to that in 1997?
Offer a terse response. 0.77. What is the ratio of the Aid flow from UN agencies (US$) in Hungary in 1993 to that in 1998?
Make the answer very short. 0.44. What is the ratio of the Aid flow from UN agencies (US$) in Iraq in 1993 to that in 1998?
Your answer should be very brief. 1.16. What is the ratio of the Aid flow from UN agencies (US$) of Hungary in 1993 to that in 1999?
Offer a very short reply. 1.08. What is the ratio of the Aid flow from UN agencies (US$) in Iraq in 1993 to that in 1999?
Offer a terse response. 0.87. What is the ratio of the Aid flow from UN agencies (US$) in Lebanon in 1993 to that in 1999?
Keep it short and to the point. 0.58. What is the ratio of the Aid flow from UN agencies (US$) in Uganda in 1993 to that in 1999?
Your answer should be very brief. 0.79. What is the ratio of the Aid flow from UN agencies (US$) in Hungary in 1994 to that in 1995?
Your answer should be compact. 0.98. What is the ratio of the Aid flow from UN agencies (US$) of Iraq in 1994 to that in 1995?
Offer a very short reply. 0.18. What is the ratio of the Aid flow from UN agencies (US$) of Lebanon in 1994 to that in 1995?
Provide a succinct answer. 0.47. What is the ratio of the Aid flow from UN agencies (US$) in Uganda in 1994 to that in 1995?
Give a very brief answer. 0.54. What is the ratio of the Aid flow from UN agencies (US$) of Hungary in 1994 to that in 1996?
Offer a very short reply. 1.57. What is the ratio of the Aid flow from UN agencies (US$) of Iraq in 1994 to that in 1996?
Make the answer very short. 1.07. What is the ratio of the Aid flow from UN agencies (US$) in Lebanon in 1994 to that in 1996?
Your response must be concise. 0.86. What is the ratio of the Aid flow from UN agencies (US$) in Uganda in 1994 to that in 1996?
Provide a short and direct response. 1.08. What is the ratio of the Aid flow from UN agencies (US$) of Hungary in 1994 to that in 1997?
Keep it short and to the point. 1.77. What is the ratio of the Aid flow from UN agencies (US$) in Iraq in 1994 to that in 1997?
Your response must be concise. 0.31. What is the ratio of the Aid flow from UN agencies (US$) in Lebanon in 1994 to that in 1997?
Keep it short and to the point. 0.61. What is the ratio of the Aid flow from UN agencies (US$) in Uganda in 1994 to that in 1997?
Give a very brief answer. 0.65. What is the ratio of the Aid flow from UN agencies (US$) in Hungary in 1994 to that in 1998?
Provide a succinct answer. 0.89. What is the ratio of the Aid flow from UN agencies (US$) of Iraq in 1994 to that in 1998?
Ensure brevity in your answer.  0.52. What is the ratio of the Aid flow from UN agencies (US$) in Lebanon in 1994 to that in 1998?
Provide a succinct answer. 0.79. What is the ratio of the Aid flow from UN agencies (US$) of Uganda in 1994 to that in 1998?
Ensure brevity in your answer.  0.86. What is the ratio of the Aid flow from UN agencies (US$) of Hungary in 1994 to that in 1999?
Offer a terse response. 2.18. What is the ratio of the Aid flow from UN agencies (US$) of Iraq in 1994 to that in 1999?
Your answer should be compact. 0.39. What is the ratio of the Aid flow from UN agencies (US$) of Lebanon in 1994 to that in 1999?
Ensure brevity in your answer.  0.46. What is the ratio of the Aid flow from UN agencies (US$) in Uganda in 1994 to that in 1999?
Keep it short and to the point. 0.68. What is the ratio of the Aid flow from UN agencies (US$) of Hungary in 1995 to that in 1996?
Ensure brevity in your answer.  1.61. What is the ratio of the Aid flow from UN agencies (US$) of Iraq in 1995 to that in 1996?
Your answer should be compact. 5.89. What is the ratio of the Aid flow from UN agencies (US$) of Lebanon in 1995 to that in 1996?
Your answer should be very brief. 1.84. What is the ratio of the Aid flow from UN agencies (US$) of Uganda in 1995 to that in 1996?
Offer a very short reply. 1.98. What is the ratio of the Aid flow from UN agencies (US$) of Hungary in 1995 to that in 1997?
Make the answer very short. 1.81. What is the ratio of the Aid flow from UN agencies (US$) of Iraq in 1995 to that in 1997?
Your answer should be compact. 1.7. What is the ratio of the Aid flow from UN agencies (US$) in Lebanon in 1995 to that in 1997?
Make the answer very short. 1.3. What is the ratio of the Aid flow from UN agencies (US$) in Uganda in 1995 to that in 1997?
Give a very brief answer. 1.2. What is the ratio of the Aid flow from UN agencies (US$) in Hungary in 1995 to that in 1998?
Offer a very short reply. 0.91. What is the ratio of the Aid flow from UN agencies (US$) of Iraq in 1995 to that in 1998?
Provide a short and direct response. 2.84. What is the ratio of the Aid flow from UN agencies (US$) in Lebanon in 1995 to that in 1998?
Provide a succinct answer. 1.68. What is the ratio of the Aid flow from UN agencies (US$) of Uganda in 1995 to that in 1998?
Offer a very short reply. 1.57. What is the ratio of the Aid flow from UN agencies (US$) of Hungary in 1995 to that in 1999?
Provide a short and direct response. 2.23. What is the ratio of the Aid flow from UN agencies (US$) of Iraq in 1995 to that in 1999?
Provide a succinct answer. 2.13. What is the ratio of the Aid flow from UN agencies (US$) of Lebanon in 1995 to that in 1999?
Make the answer very short. 0.98. What is the ratio of the Aid flow from UN agencies (US$) of Uganda in 1995 to that in 1999?
Your answer should be very brief. 1.25. What is the ratio of the Aid flow from UN agencies (US$) in Hungary in 1996 to that in 1997?
Provide a succinct answer. 1.12. What is the ratio of the Aid flow from UN agencies (US$) in Iraq in 1996 to that in 1997?
Offer a terse response. 0.29. What is the ratio of the Aid flow from UN agencies (US$) in Lebanon in 1996 to that in 1997?
Keep it short and to the point. 0.71. What is the ratio of the Aid flow from UN agencies (US$) of Uganda in 1996 to that in 1997?
Provide a short and direct response. 0.61. What is the ratio of the Aid flow from UN agencies (US$) in Hungary in 1996 to that in 1998?
Your response must be concise. 0.56. What is the ratio of the Aid flow from UN agencies (US$) in Iraq in 1996 to that in 1998?
Offer a terse response. 0.48. What is the ratio of the Aid flow from UN agencies (US$) of Lebanon in 1996 to that in 1998?
Provide a short and direct response. 0.91. What is the ratio of the Aid flow from UN agencies (US$) in Uganda in 1996 to that in 1998?
Keep it short and to the point. 0.8. What is the ratio of the Aid flow from UN agencies (US$) in Hungary in 1996 to that in 1999?
Give a very brief answer. 1.38. What is the ratio of the Aid flow from UN agencies (US$) of Iraq in 1996 to that in 1999?
Your response must be concise. 0.36. What is the ratio of the Aid flow from UN agencies (US$) in Lebanon in 1996 to that in 1999?
Offer a terse response. 0.53. What is the ratio of the Aid flow from UN agencies (US$) of Uganda in 1996 to that in 1999?
Your response must be concise. 0.63. What is the ratio of the Aid flow from UN agencies (US$) in Hungary in 1997 to that in 1998?
Ensure brevity in your answer.  0.5. What is the ratio of the Aid flow from UN agencies (US$) in Iraq in 1997 to that in 1998?
Keep it short and to the point. 1.67. What is the ratio of the Aid flow from UN agencies (US$) of Lebanon in 1997 to that in 1998?
Your answer should be compact. 1.29. What is the ratio of the Aid flow from UN agencies (US$) of Uganda in 1997 to that in 1998?
Give a very brief answer. 1.31. What is the ratio of the Aid flow from UN agencies (US$) of Hungary in 1997 to that in 1999?
Make the answer very short. 1.23. What is the ratio of the Aid flow from UN agencies (US$) of Iraq in 1997 to that in 1999?
Give a very brief answer. 1.26. What is the ratio of the Aid flow from UN agencies (US$) of Lebanon in 1997 to that in 1999?
Keep it short and to the point. 0.76. What is the ratio of the Aid flow from UN agencies (US$) of Uganda in 1997 to that in 1999?
Your response must be concise. 1.04. What is the ratio of the Aid flow from UN agencies (US$) of Hungary in 1998 to that in 1999?
Give a very brief answer. 2.46. What is the ratio of the Aid flow from UN agencies (US$) of Lebanon in 1998 to that in 1999?
Give a very brief answer. 0.58. What is the ratio of the Aid flow from UN agencies (US$) of Uganda in 1998 to that in 1999?
Make the answer very short. 0.79. What is the difference between the highest and the second highest Aid flow from UN agencies (US$) in Iraq?
Give a very brief answer. 1.72e+06. What is the difference between the highest and the second highest Aid flow from UN agencies (US$) of Lebanon?
Give a very brief answer. 4.00e+04. What is the difference between the highest and the second highest Aid flow from UN agencies (US$) of Uganda?
Provide a succinct answer. 5.70e+05. What is the difference between the highest and the lowest Aid flow from UN agencies (US$) of Hungary?
Your response must be concise. 5.70e+05. What is the difference between the highest and the lowest Aid flow from UN agencies (US$) of Iraq?
Offer a terse response. 3.47e+06. What is the difference between the highest and the lowest Aid flow from UN agencies (US$) of Lebanon?
Ensure brevity in your answer.  1.19e+06. What is the difference between the highest and the lowest Aid flow from UN agencies (US$) in Uganda?
Your answer should be very brief. 1.67e+06. 